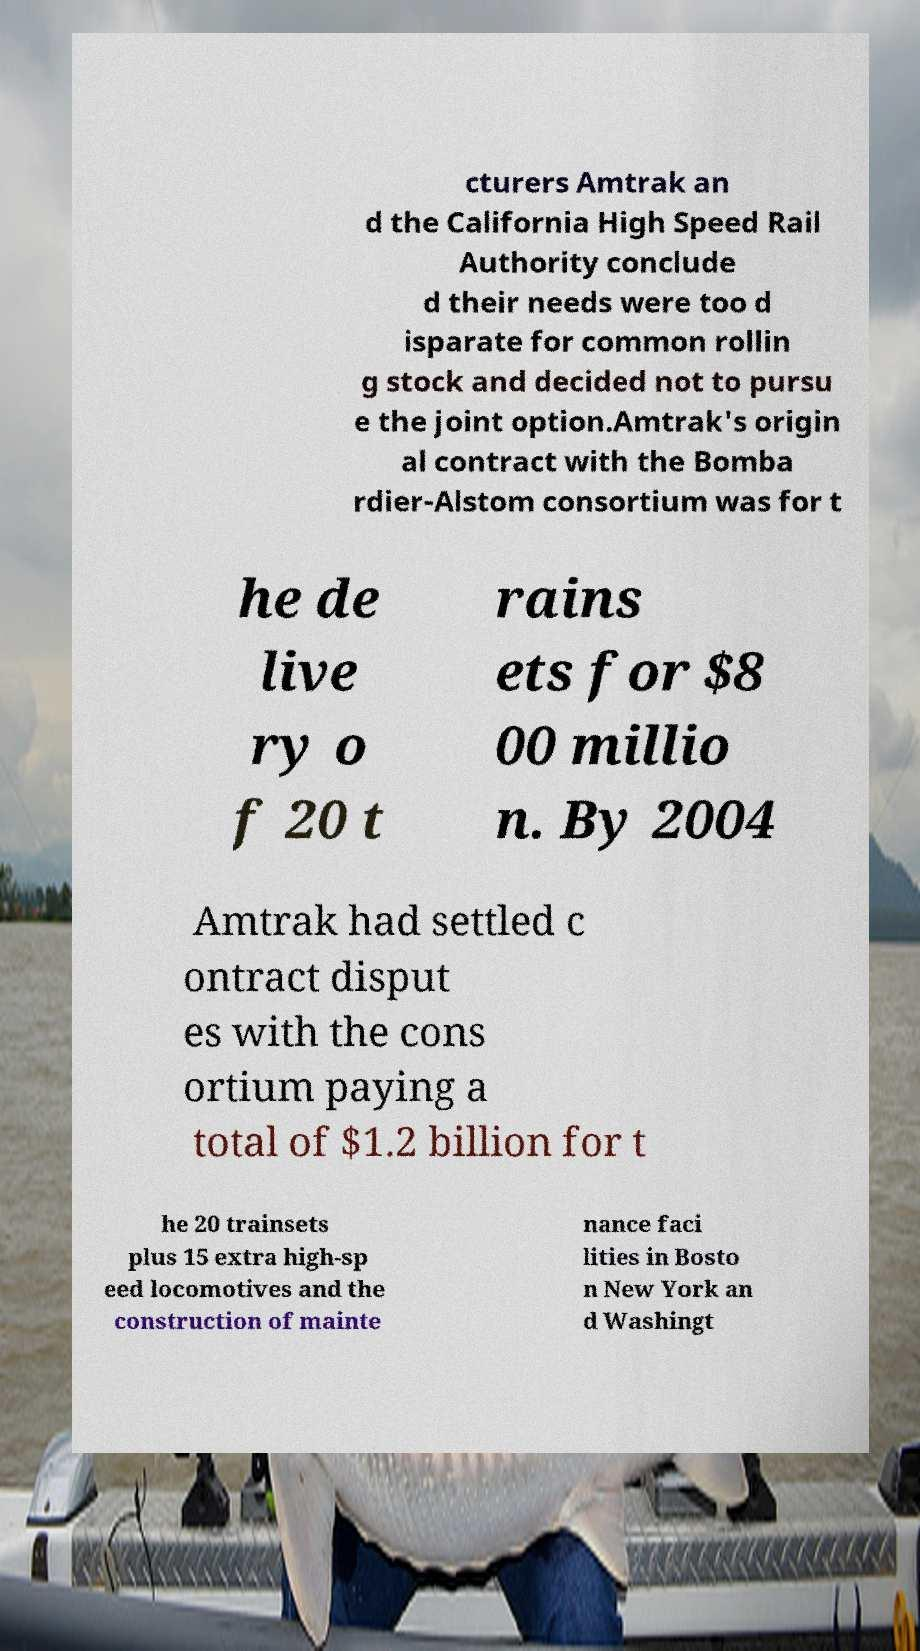Could you assist in decoding the text presented in this image and type it out clearly? cturers Amtrak an d the California High Speed Rail Authority conclude d their needs were too d isparate for common rollin g stock and decided not to pursu e the joint option.Amtrak's origin al contract with the Bomba rdier-Alstom consortium was for t he de live ry o f 20 t rains ets for $8 00 millio n. By 2004 Amtrak had settled c ontract disput es with the cons ortium paying a total of $1.2 billion for t he 20 trainsets plus 15 extra high-sp eed locomotives and the construction of mainte nance faci lities in Bosto n New York an d Washingt 